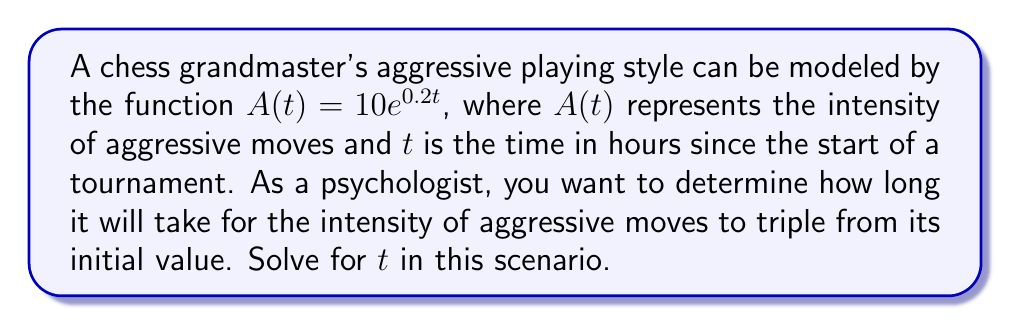What is the answer to this math problem? To solve this problem, we'll follow these steps:

1) The initial intensity is given by $A(0) = 10e^{0.2(0)} = 10$

2) We want to find when the intensity triples, so we're looking for $A(t) = 3 \cdot 10 = 30$

3) Set up the equation:
   $$30 = 10e^{0.2t}$$

4) Divide both sides by 10:
   $$3 = e^{0.2t}$$

5) Take the natural logarithm of both sides:
   $$\ln(3) = \ln(e^{0.2t})$$

6) Simplify the right side using the property of logarithms:
   $$\ln(3) = 0.2t$$

7) Solve for $t$ by dividing both sides by 0.2:
   $$t = \frac{\ln(3)}{0.2}$$

8) Calculate the final value:
   $$t = \frac{\ln(3)}{0.2} \approx 5.4931$$

Therefore, it will take approximately 5.4931 hours for the intensity of aggressive moves to triple from its initial value.
Answer: $t \approx 5.4931$ hours 